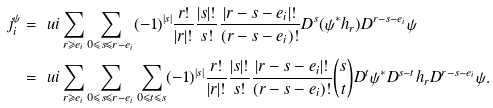<formula> <loc_0><loc_0><loc_500><loc_500>j ^ { \psi } _ { i } & = \ u i \sum _ { r \geqslant e _ { i } } \sum _ { 0 \leqslant s \leqslant r - e _ { i } } ( - 1 ) ^ { | s | } \frac { r ! } { | r | ! } \frac { | s | ! } { s ! } \frac { | r - s - e _ { i } | ! } { ( r - s - e _ { i } ) ! } D ^ { s } ( \psi ^ { * } h _ { r } ) D ^ { r - s - e _ { i } } \psi \\ & = \ u i \sum _ { r \geqslant e _ { i } } \sum _ { 0 \leqslant s \leqslant r - e _ { i } } \sum _ { 0 \leqslant t \leqslant s } ( - 1 ) ^ { | s | } \frac { r ! } { | r | ! } \frac { | s | ! } { s ! } \frac { | r - s - e _ { i } | ! } { ( r - s - e _ { i } ) ! } \binom { s } { t } D ^ { t } \psi ^ { * } D ^ { s - t } h _ { r } D ^ { r - s - e _ { i } } \psi .</formula> 